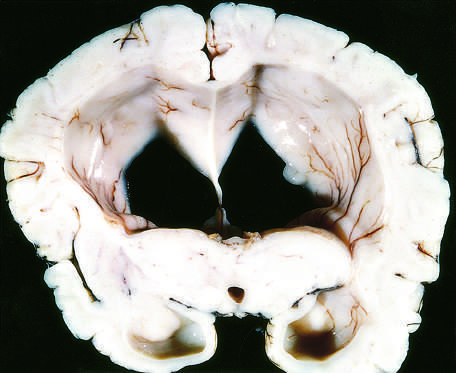what are such changes associated with?
Answer the question using a single word or phrase. Dangerous increase in intra-cranial pressure 